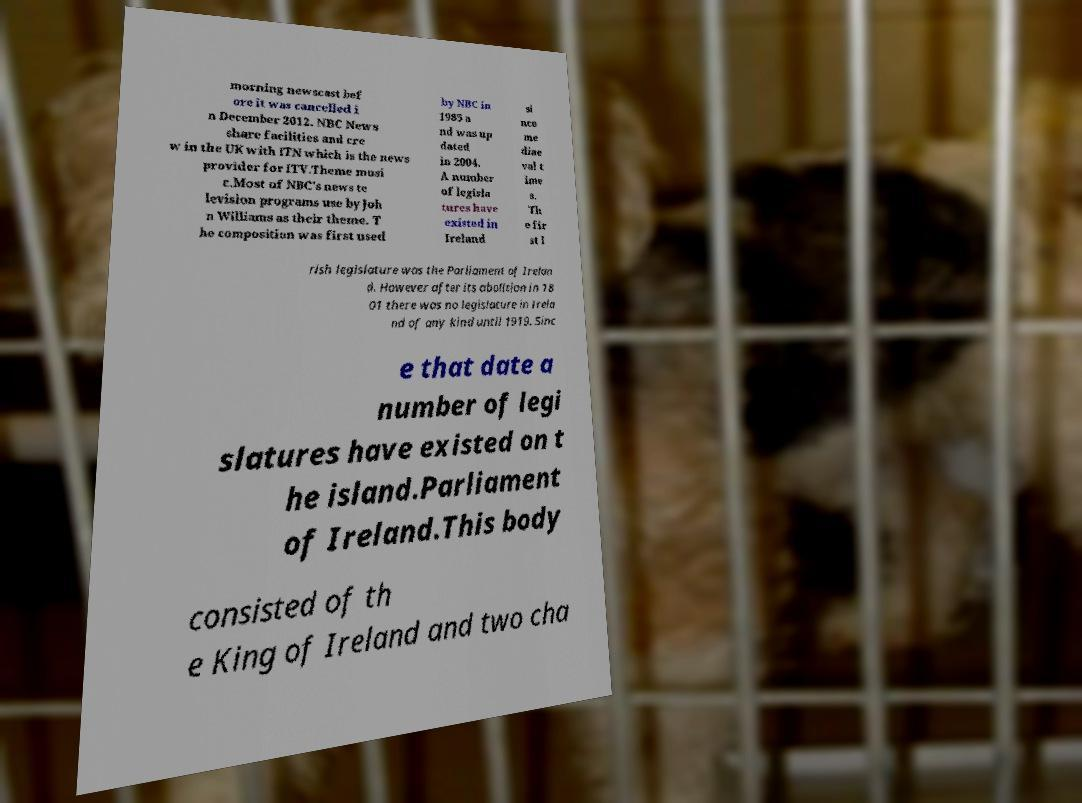I need the written content from this picture converted into text. Can you do that? morning newscast bef ore it was cancelled i n December 2012. NBC News share facilities and cre w in the UK with ITN which is the news provider for ITV.Theme musi c.Most of NBC's news te levision programs use by Joh n Williams as their theme. T he composition was first used by NBC in 1985 a nd was up dated in 2004. A number of legisla tures have existed in Ireland si nce me diae val t ime s. Th e fir st I rish legislature was the Parliament of Irelan d. However after its abolition in 18 01 there was no legislature in Irela nd of any kind until 1919. Sinc e that date a number of legi slatures have existed on t he island.Parliament of Ireland.This body consisted of th e King of Ireland and two cha 